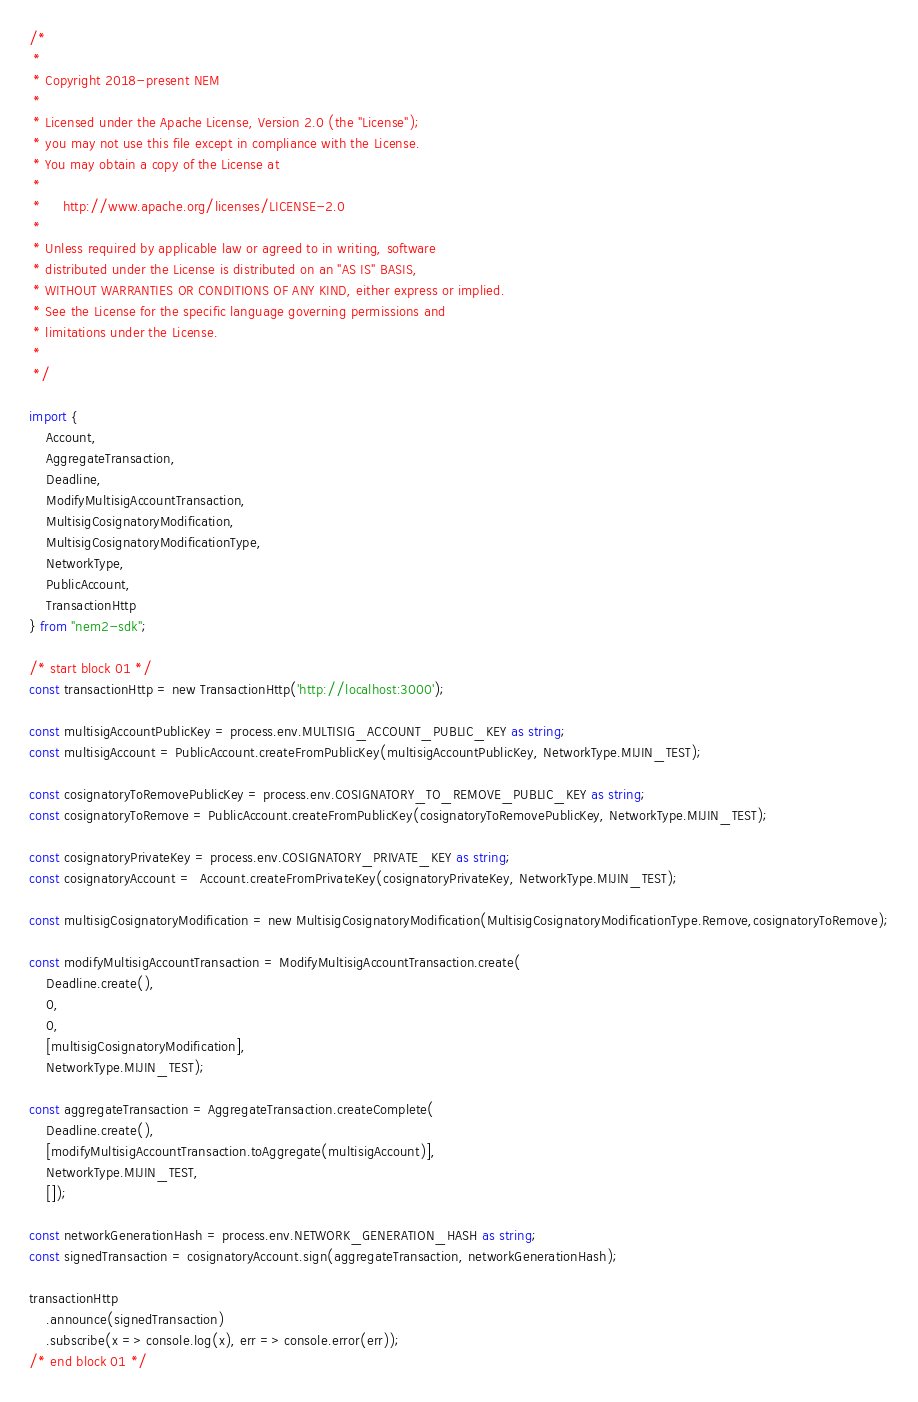<code> <loc_0><loc_0><loc_500><loc_500><_TypeScript_>/*
 *
 * Copyright 2018-present NEM
 *
 * Licensed under the Apache License, Version 2.0 (the "License");
 * you may not use this file except in compliance with the License.
 * You may obtain a copy of the License at
 *
 *     http://www.apache.org/licenses/LICENSE-2.0
 *
 * Unless required by applicable law or agreed to in writing, software
 * distributed under the License is distributed on an "AS IS" BASIS,
 * WITHOUT WARRANTIES OR CONDITIONS OF ANY KIND, either express or implied.
 * See the License for the specific language governing permissions and
 * limitations under the License.
 *
 */

import {
    Account,
    AggregateTransaction,
    Deadline,
    ModifyMultisigAccountTransaction,
    MultisigCosignatoryModification,
    MultisigCosignatoryModificationType,
    NetworkType,
    PublicAccount,
    TransactionHttp
} from "nem2-sdk";

/* start block 01 */
const transactionHttp = new TransactionHttp('http://localhost:3000');

const multisigAccountPublicKey = process.env.MULTISIG_ACCOUNT_PUBLIC_KEY as string;
const multisigAccount = PublicAccount.createFromPublicKey(multisigAccountPublicKey, NetworkType.MIJIN_TEST);

const cosignatoryToRemovePublicKey = process.env.COSIGNATORY_TO_REMOVE_PUBLIC_KEY as string;
const cosignatoryToRemove = PublicAccount.createFromPublicKey(cosignatoryToRemovePublicKey, NetworkType.MIJIN_TEST);

const cosignatoryPrivateKey = process.env.COSIGNATORY_PRIVATE_KEY as string;
const cosignatoryAccount =  Account.createFromPrivateKey(cosignatoryPrivateKey, NetworkType.MIJIN_TEST);

const multisigCosignatoryModification = new MultisigCosignatoryModification(MultisigCosignatoryModificationType.Remove,cosignatoryToRemove);

const modifyMultisigAccountTransaction = ModifyMultisigAccountTransaction.create(
    Deadline.create(),
    0,
    0,
    [multisigCosignatoryModification],
    NetworkType.MIJIN_TEST);

const aggregateTransaction = AggregateTransaction.createComplete(
    Deadline.create(),
    [modifyMultisigAccountTransaction.toAggregate(multisigAccount)],
    NetworkType.MIJIN_TEST,
    []);

const networkGenerationHash = process.env.NETWORK_GENERATION_HASH as string;
const signedTransaction = cosignatoryAccount.sign(aggregateTransaction, networkGenerationHash);

transactionHttp
    .announce(signedTransaction)
    .subscribe(x => console.log(x), err => console.error(err));
/* end block 01 */
</code> 